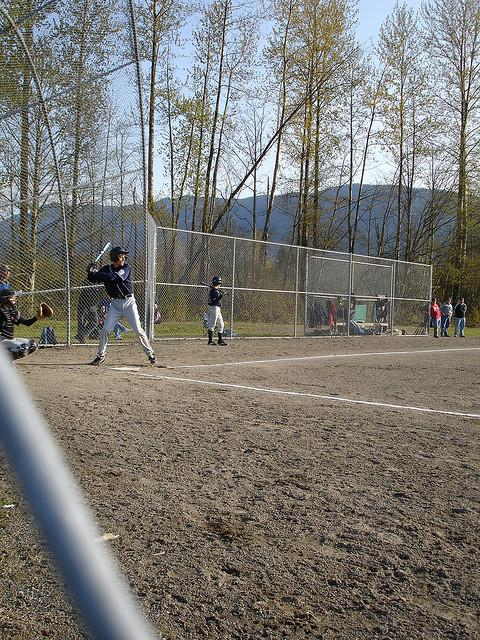What shape is the object used to play this game? round 